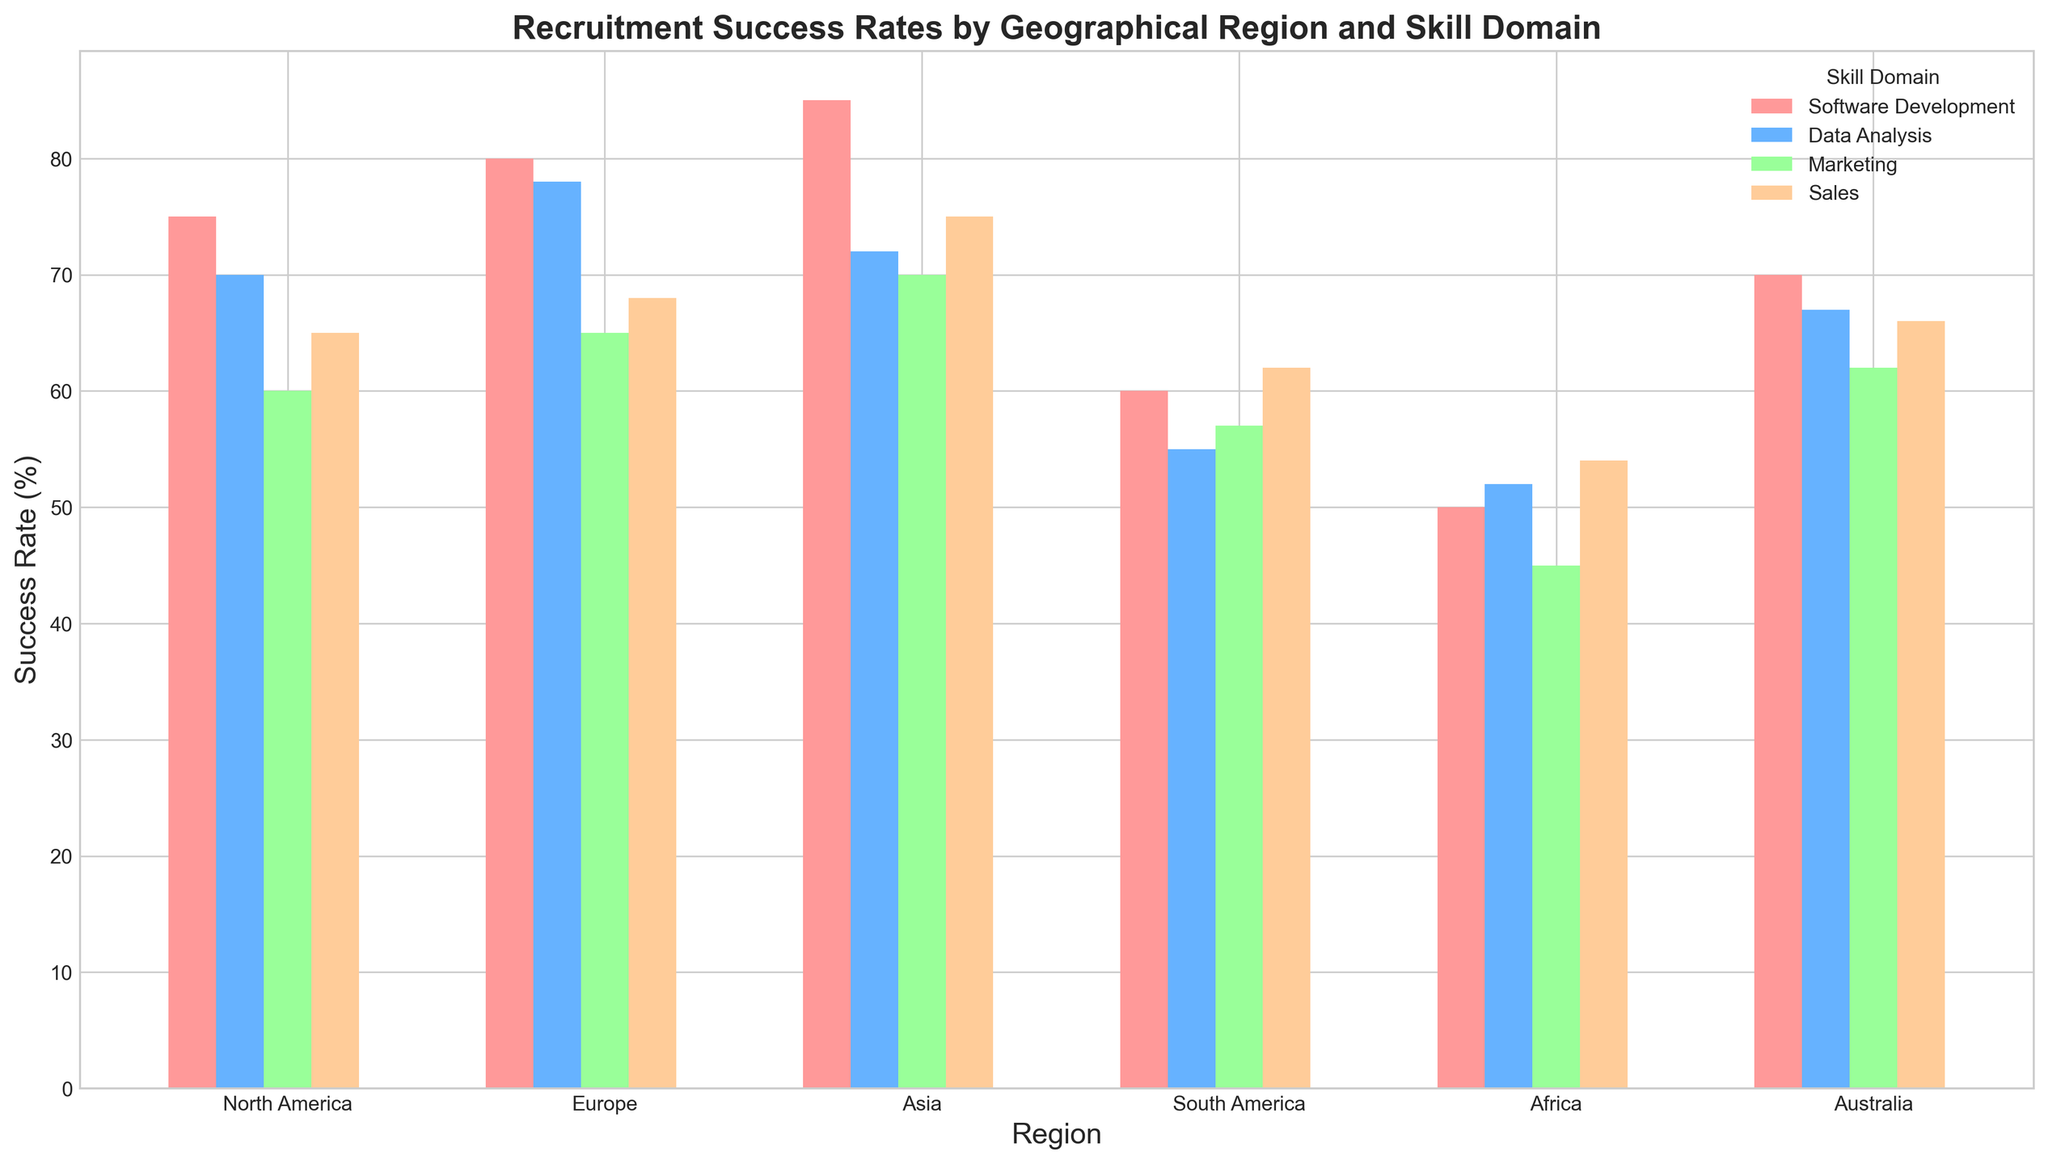What's the region with the highest success rate in Software Development? To identify the region with the highest success rate in Software Development, look for the tallest bar in the Software Development color segment. In this case, it's the bar corresponding to Asia.
Answer: Asia Which skill domain has the lowest success rate in Africa? To find the skill domain with the lowest success rate in Africa, observe the shortest bar within the bars representing Africa. Here, the shortest bar corresponds to the Marketing skill domain.
Answer: Marketing What is the difference in success rates for Sales between Asia and North America? To find this difference, locate the bars for Sales in both Asia and North America. The heights represent success rates of 75 for Asia and 65 for North America. Thus, the difference is 75 - 65.
Answer: 10 Which skill domain, on average, has the highest success rate across all regions? Calculate the average success rate for each skill domain across all regions:
- Software Development: (75 + 80 + 85 + 60 + 50 + 70) / 6 = 420 / 6 = 70
- Data Analysis: (70 + 78 + 72 + 55 + 52 + 67) / 6 = 394 / 6 ≈ 65.67
- Marketing: (60 + 65 + 70 + 57 + 45 + 62) / 6 = 359 / 6 ≈ 59.83
- Sales: (65 + 68 + 75 + 62 + 54 + 66) / 6 = 390 / 6 = 65
From these calculations, the highest average is for Software Development.
Answer: Software Development Which region shows consistent success rates across all skill domains? Consistency here means minimal variation in bar heights across different skill domains within the same regional group. Visual inspection reveals that the bars for North America and Australia look quite similar in height across different domains. Upon closer inspection, Australia's bars show the least variability.
Answer: Australia Compare the success rate for Data Analysis between Europe and South America—are they more than 20% apart? Find the success rates for Data Analysis in both regions: Europe has 78% and South America has 55%. The difference is 78 - 55 = 23%. Since 23% is more than 20%, the answer is yes.
Answer: Yes List all skill domains in which Europe outperforms South America. Compare each skill domain's success rate in Europe and South America:
- Software Development: Europe (80) vs South America (60) – Europe is higher.
- Data Analysis: Europe (78) vs South America (55) – Europe is higher.
- Marketing: Europe (65) vs South America (57) – Europe is higher.
- Sales: Europe (68) vs South America (62) – Europe is higher.
So, Europe outperforms South America in all skill domains.
Answer: All skill domains What is the combined success rate for Marketing across all regions? Add the success rates for Marketing in each region: 60 (North America) + 65 (Europe) + 70 (Asia) + 57 (South America) + 45 (Africa) + 62 (Australia) = 359.
Answer: 359 Which region has the greatest disparity between the highest and lowest success rates within skill domains? Determine the disparity for each region by subtracting the lowest success rate from the highest within the same region:
- North America: 75 - 60 = 15
- Europe: 80 - 65 = 15
- Asia: 85 - 70 = 15
- South America: 62 - 55 = 7
- Africa: 54 - 45 = 9
- Australia: 70 - 62 = 8
The disparities for North America, Europe, and Asia are equal and maximal at 15.
Answer: North America, Europe, Asia Which skill domain shows the most improvement from Africa to Asia? To find the most improvement, calculate the difference for each skill domain between Africa and Asia:
- Software Development: 85 - 50 = 35
- Data Analysis: 72 - 52 = 20
- Marketing: 70 - 45 = 25
- Sales: 75 - 54 = 21
The most improvement is in Software Development with a difference of 35.
Answer: Software Development 